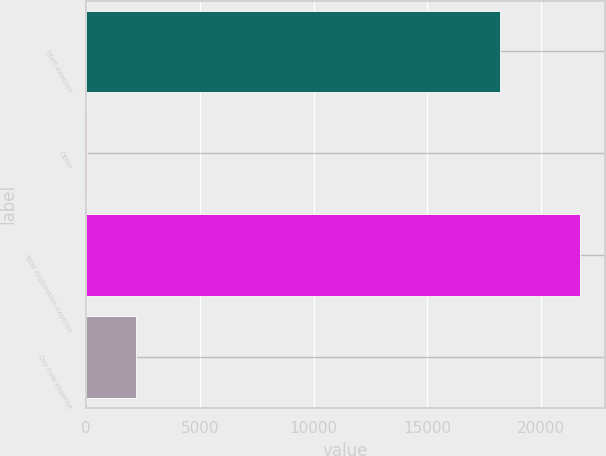<chart> <loc_0><loc_0><loc_500><loc_500><bar_chart><fcel>Staff expense<fcel>Other<fcel>Total exploration expense<fcel>Dry hole expense<nl><fcel>18198<fcel>39<fcel>21701<fcel>2205.2<nl></chart> 